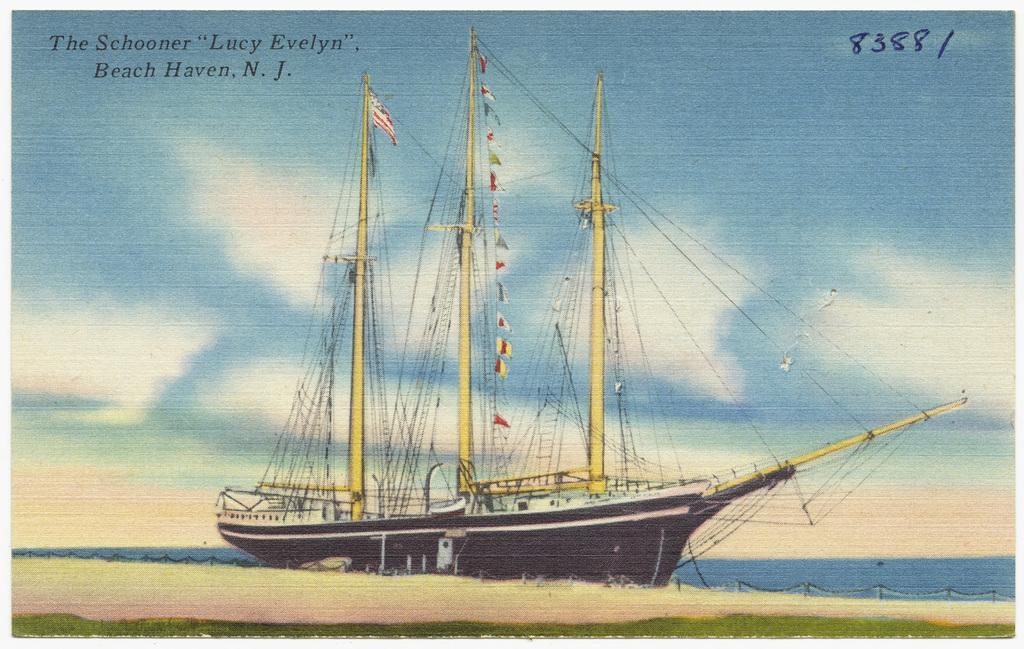Can you describe this image briefly? This image looks like a painting in which I can see a boat in the water, fence and the sky. 